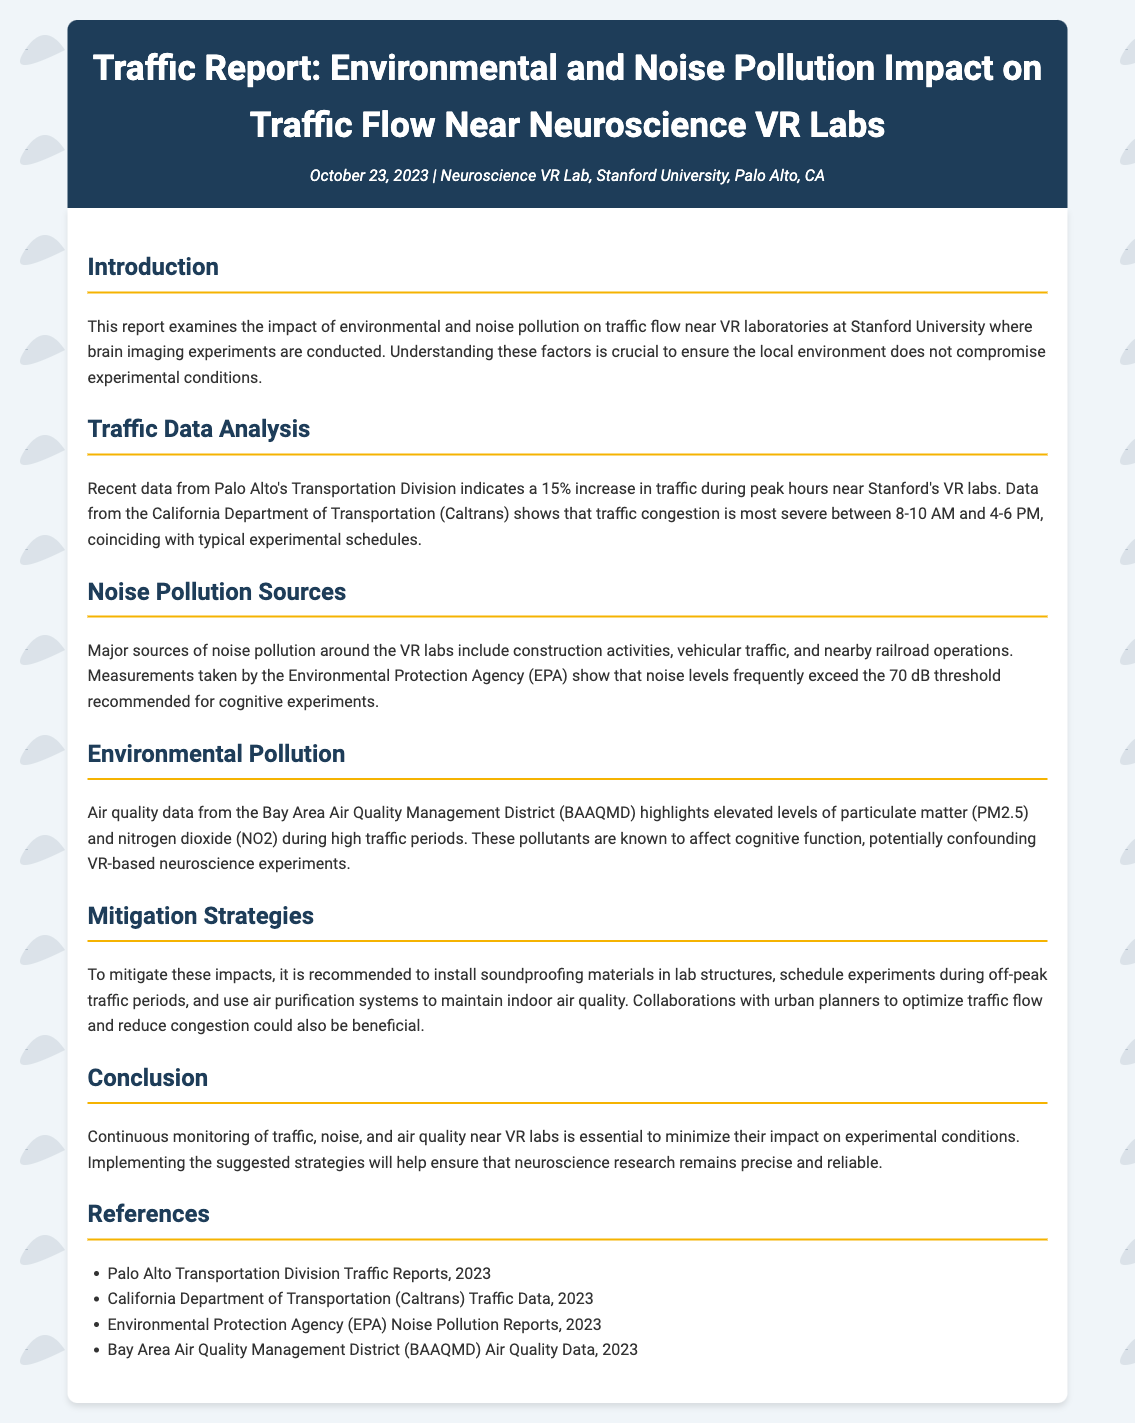What was the date of the report? The report is dated October 23, 2023.
Answer: October 23, 2023 What percentage increase in traffic was observed? There is a 15% increase in traffic during peak hours.
Answer: 15% What are the major sources of noise pollution listed? Major sources include construction activities, vehicular traffic, and nearby railroad operations.
Answer: Construction activities, vehicular traffic, and nearby railroad operations Which pollutants are mentioned as elevated around the VR labs? Elevated levels of particulate matter (PM2.5) and nitrogen dioxide (NO2) are highlighted.
Answer: Particulate matter (PM2.5) and nitrogen dioxide (NO2) What is the recommended noise level threshold for cognitive experiments? The recommended noise level threshold is 70 dB.
Answer: 70 dB What is a suggested mitigation strategy for noise pollution? One suggested strategy is to install soundproofing materials in lab structures.
Answer: Install soundproofing materials in lab structures During which hours is traffic congestion most severe? Traffic congestion is most severe between 8-10 AM and 4-6 PM.
Answer: 8-10 AM and 4-6 PM Why is continuous monitoring essential according to the conclusion? Continuous monitoring is essential to minimize the impact on experimental conditions.
Answer: Minimize the impact on experimental conditions What is the affiliation of the VR lab mentioned in the report? The VR lab is affiliated with Stanford University.
Answer: Stanford University 